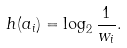Convert formula to latex. <formula><loc_0><loc_0><loc_500><loc_500>h ( a _ { i } ) = \log _ { 2 } { \frac { 1 } { w _ { i } } } .</formula> 